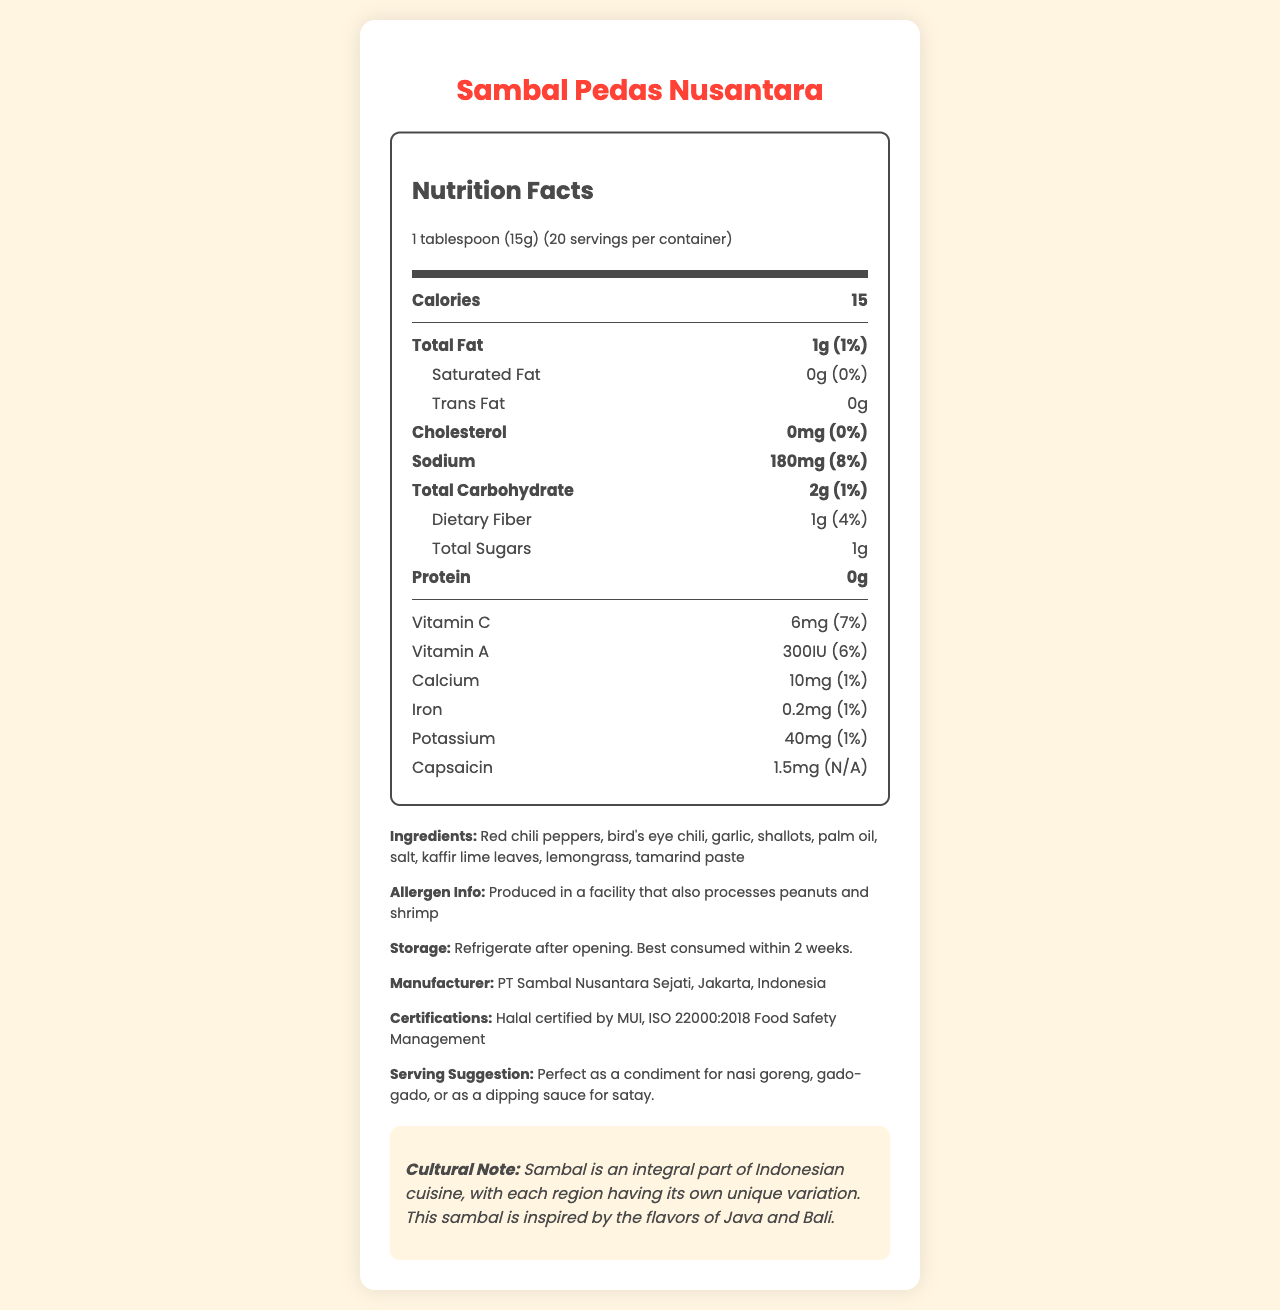what is the serving size of Sambal Pedas Nusantara? The serving size is clearly mentioned under nutrition facts with the amount of 1 tablespoon (15g).
Answer: 1 tablespoon (15g) how many servings are in one container? The document states that there are 20 servings per container.
Answer: 20 how many calories are in one serving of sambal? The calorie count per serving is listed as 15 calories.
Answer: 15 calories what is the amount of vitamin C in one serving? The amount of vitamin C per serving is 6mg as indicated in the nutrition facts.
Answer: 6mg what is the main ingredient in Sambal Pedas Nusantara? The first ingredient listed is red chili peppers, which is typically the primary ingredient.
Answer: Red chili peppers what is the total fat percentage of the daily value in one serving? The total fat content in one serving represents 1% of the daily value.
Answer: 1% how much sodium is in one serving? The sodium content per serving is listed as 180mg in the nutrition facts.
Answer: 180mg which of the following certifications does Sambal Pedas Nusantara have? A. Organic B. Halal C. Kosher D. Fair Trade The document mentions that the sambal is Halal certified by MUI.
Answer: B. Halal how should the sambal be stored after opening? A. At room temperature B. In the freezer C. In the refrigerator D. In a dry place The storage instructions specifically state to refrigerate after opening.
Answer: C. In the refrigerator does Sambal Pedas Nusantara contain any trans fat? The nutrition facts indicate that the trans fat content is 0g, implying there is no trans fat.
Answer: No does the label indicate any allergens? The allergen information mentions that it is produced in a facility that processes peanuts and shrimp.
Answer: Yes can the document tell us the exact amount of fiber in one serving? The document specifies that there is 1g of dietary fiber per serving.
Answer: Yes what is the purpose of capsaicin in sambal? The document only states the amount of capsaicin per serving and not its purpose or benefits.
Answer: Cannot be determined briefly summarize the main idea of the document. This explanation covers all aspects highlighted in the document, summarizing the nutrition content, additional product details, and cultural significance of the sambal.
Answer: The document provides the nutrition facts for Sambal Pedas Nusantara, including detailed information on serving size, calories, fats, vitamins, minerals, ingredients, allergen information, storage instructions, manufacturer details, and cultural notes. is the product suitable for people avoiding peanuts due to allergies? The allergen information states that it is produced in a facility that processes peanuts, which may pose a risk.
Answer: No 